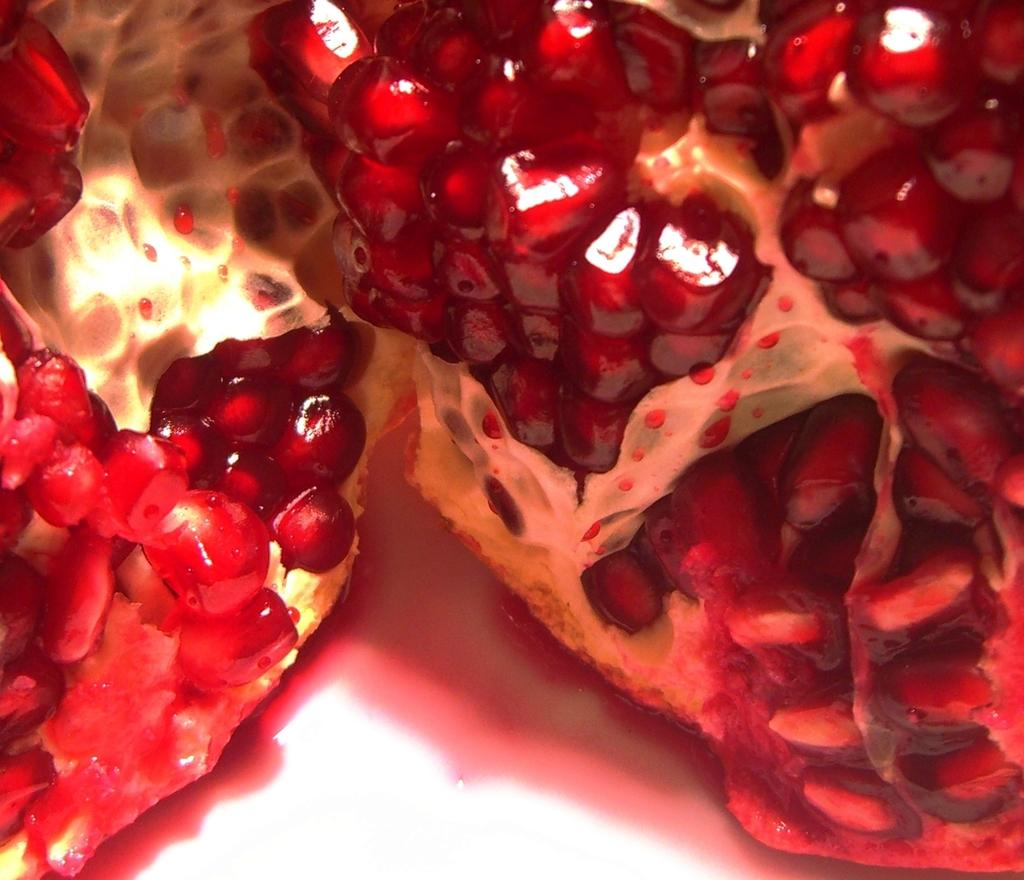What type of food item is visible in the image? There are pomegranate seeds in the image. What is the color of the pomegranate seeds? The pomegranate seeds are red in color. What type of juice can be seen being advertised in the image? There is no advertisement or juice present in the image; it only features pomegranate seeds. What type of fruit is visible in the image? The image only features pomegranate seeds, not the whole fruit. 